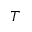<formula> <loc_0><loc_0><loc_500><loc_500>T</formula> 